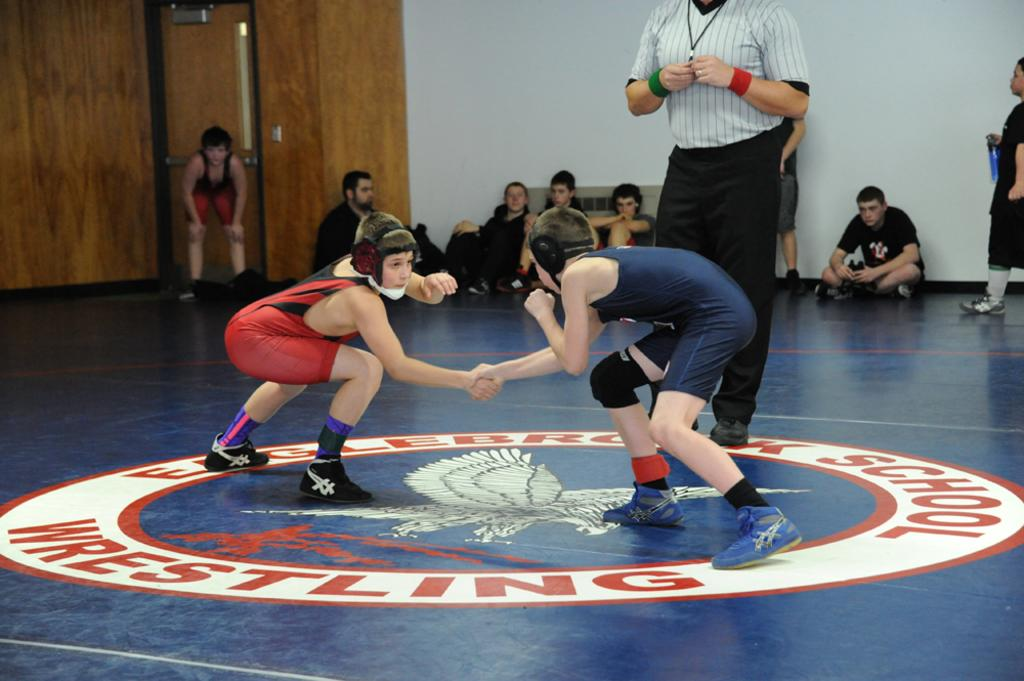<image>
Create a compact narrative representing the image presented. Two young boys are beginning a wrestling match and it says Eaglebrooke School Wrestling on the mat. 